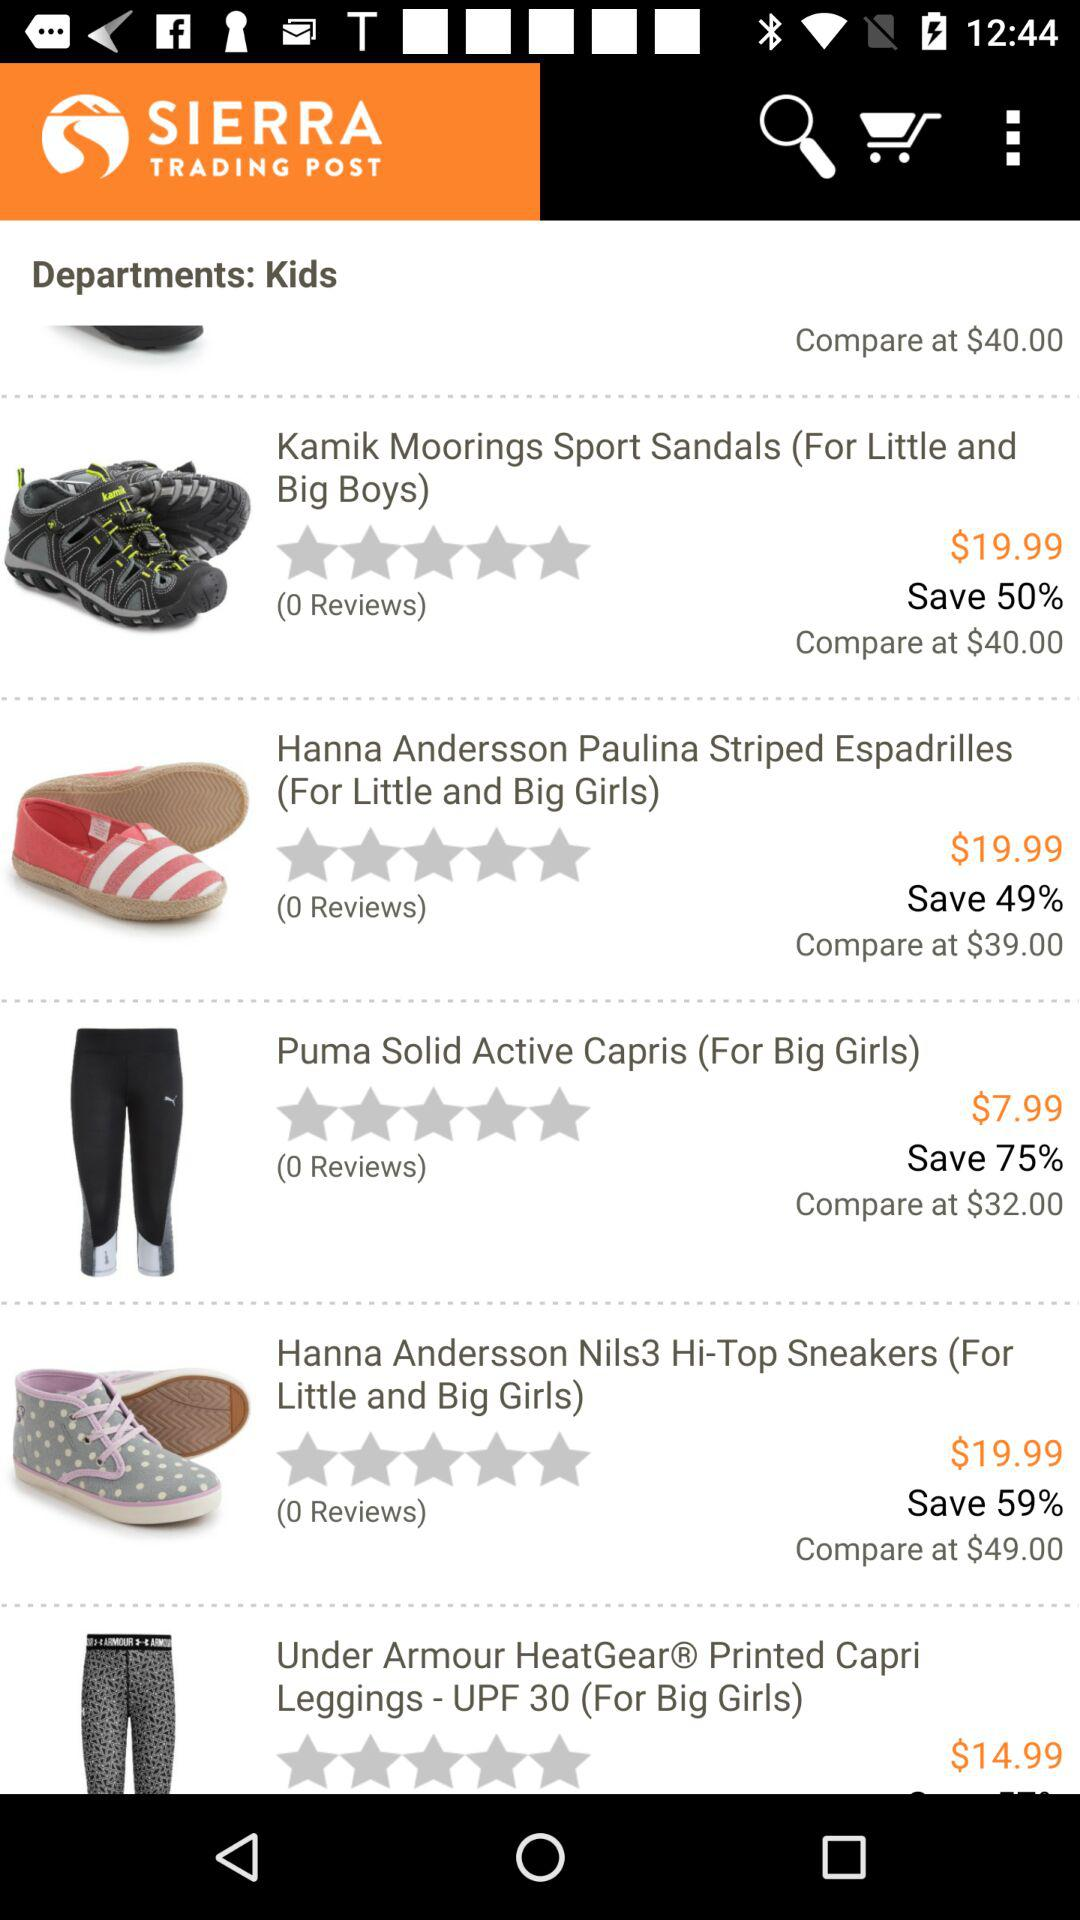What's the comparable price of "Puma Solid Active Capris"? The comparable price of "Puma Solid Active Capris" is $32.00. 